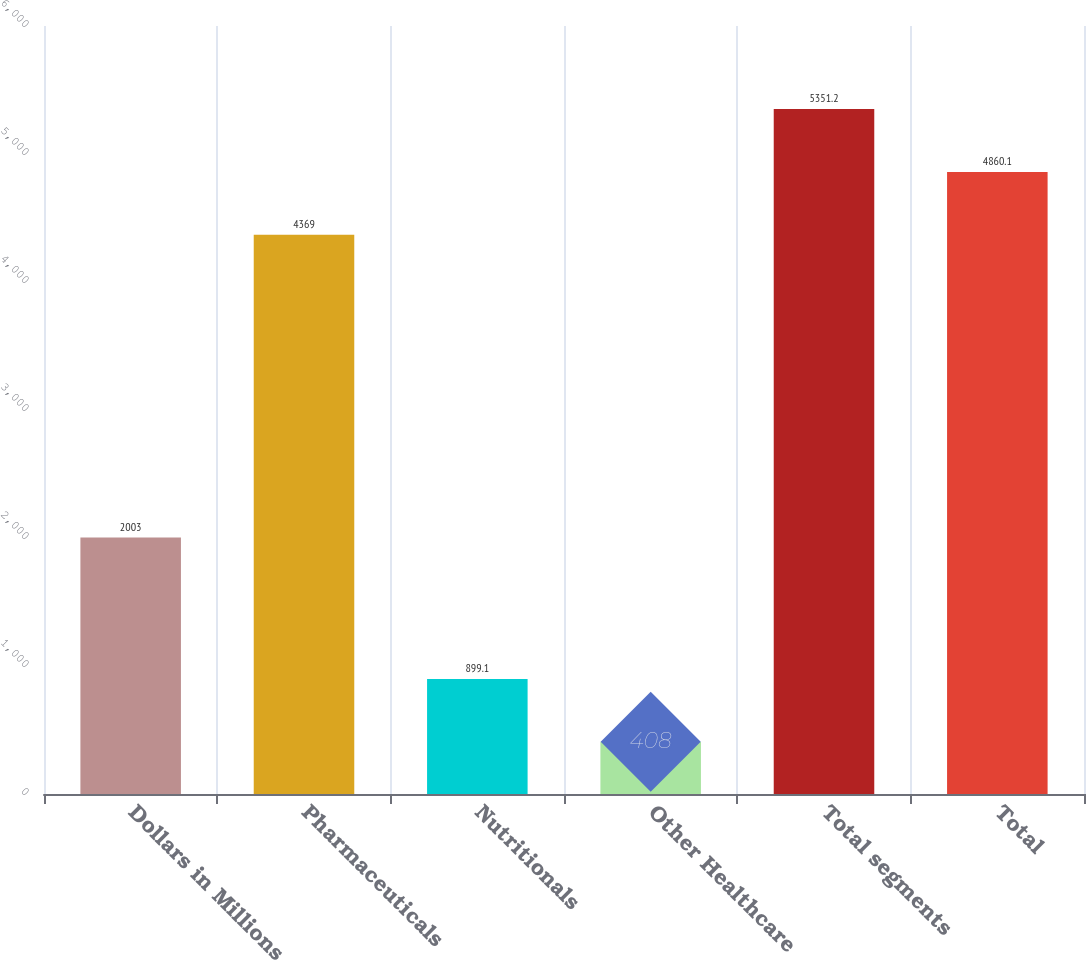<chart> <loc_0><loc_0><loc_500><loc_500><bar_chart><fcel>Dollars in Millions<fcel>Pharmaceuticals<fcel>Nutritionals<fcel>Other Healthcare<fcel>Total segments<fcel>Total<nl><fcel>2003<fcel>4369<fcel>899.1<fcel>408<fcel>5351.2<fcel>4860.1<nl></chart> 